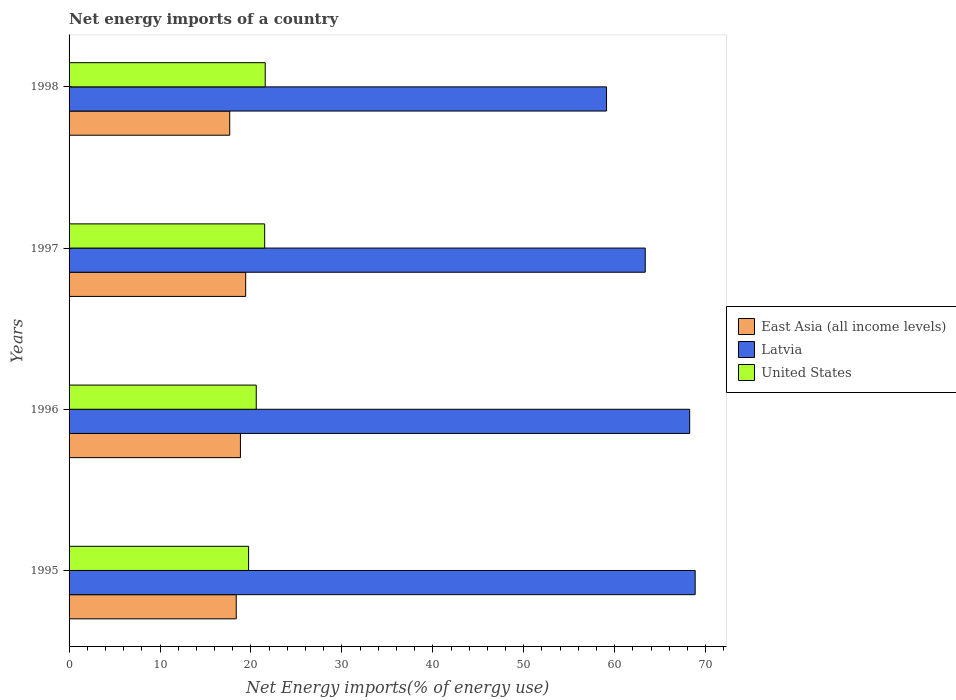How many different coloured bars are there?
Make the answer very short. 3. How many groups of bars are there?
Offer a terse response. 4. How many bars are there on the 2nd tick from the top?
Offer a terse response. 3. How many bars are there on the 1st tick from the bottom?
Give a very brief answer. 3. In how many cases, is the number of bars for a given year not equal to the number of legend labels?
Offer a very short reply. 0. What is the net energy imports in Latvia in 1997?
Offer a terse response. 63.36. Across all years, what is the maximum net energy imports in Latvia?
Provide a short and direct response. 68.85. Across all years, what is the minimum net energy imports in Latvia?
Your response must be concise. 59.1. In which year was the net energy imports in United States minimum?
Your response must be concise. 1995. What is the total net energy imports in East Asia (all income levels) in the graph?
Keep it short and to the point. 74.31. What is the difference between the net energy imports in East Asia (all income levels) in 1997 and that in 1998?
Your answer should be very brief. 1.75. What is the difference between the net energy imports in East Asia (all income levels) in 1996 and the net energy imports in United States in 1995?
Give a very brief answer. -0.9. What is the average net energy imports in United States per year?
Make the answer very short. 20.85. In the year 1995, what is the difference between the net energy imports in Latvia and net energy imports in United States?
Give a very brief answer. 49.11. What is the ratio of the net energy imports in United States in 1997 to that in 1998?
Provide a succinct answer. 1. What is the difference between the highest and the second highest net energy imports in Latvia?
Offer a terse response. 0.6. What is the difference between the highest and the lowest net energy imports in Latvia?
Make the answer very short. 9.75. In how many years, is the net energy imports in East Asia (all income levels) greater than the average net energy imports in East Asia (all income levels) taken over all years?
Ensure brevity in your answer.  2. What does the 2nd bar from the top in 1995 represents?
Your answer should be very brief. Latvia. What does the 2nd bar from the bottom in 1996 represents?
Provide a short and direct response. Latvia. How many bars are there?
Give a very brief answer. 12. How many years are there in the graph?
Keep it short and to the point. 4. What is the difference between two consecutive major ticks on the X-axis?
Offer a terse response. 10. Does the graph contain any zero values?
Offer a terse response. No. What is the title of the graph?
Your answer should be very brief. Net energy imports of a country. What is the label or title of the X-axis?
Your response must be concise. Net Energy imports(% of energy use). What is the label or title of the Y-axis?
Provide a short and direct response. Years. What is the Net Energy imports(% of energy use) in East Asia (all income levels) in 1995?
Offer a terse response. 18.38. What is the Net Energy imports(% of energy use) of Latvia in 1995?
Your response must be concise. 68.85. What is the Net Energy imports(% of energy use) in United States in 1995?
Give a very brief answer. 19.74. What is the Net Energy imports(% of energy use) of East Asia (all income levels) in 1996?
Provide a short and direct response. 18.84. What is the Net Energy imports(% of energy use) in Latvia in 1996?
Give a very brief answer. 68.25. What is the Net Energy imports(% of energy use) of United States in 1996?
Provide a short and direct response. 20.58. What is the Net Energy imports(% of energy use) of East Asia (all income levels) in 1997?
Your response must be concise. 19.42. What is the Net Energy imports(% of energy use) in Latvia in 1997?
Give a very brief answer. 63.36. What is the Net Energy imports(% of energy use) of United States in 1997?
Your response must be concise. 21.51. What is the Net Energy imports(% of energy use) in East Asia (all income levels) in 1998?
Your answer should be very brief. 17.67. What is the Net Energy imports(% of energy use) in Latvia in 1998?
Offer a very short reply. 59.1. What is the Net Energy imports(% of energy use) in United States in 1998?
Make the answer very short. 21.57. Across all years, what is the maximum Net Energy imports(% of energy use) of East Asia (all income levels)?
Ensure brevity in your answer.  19.42. Across all years, what is the maximum Net Energy imports(% of energy use) of Latvia?
Your response must be concise. 68.85. Across all years, what is the maximum Net Energy imports(% of energy use) in United States?
Your answer should be very brief. 21.57. Across all years, what is the minimum Net Energy imports(% of energy use) of East Asia (all income levels)?
Provide a succinct answer. 17.67. Across all years, what is the minimum Net Energy imports(% of energy use) of Latvia?
Make the answer very short. 59.1. Across all years, what is the minimum Net Energy imports(% of energy use) in United States?
Make the answer very short. 19.74. What is the total Net Energy imports(% of energy use) in East Asia (all income levels) in the graph?
Your answer should be very brief. 74.31. What is the total Net Energy imports(% of energy use) of Latvia in the graph?
Your answer should be very brief. 259.55. What is the total Net Energy imports(% of energy use) in United States in the graph?
Offer a very short reply. 83.4. What is the difference between the Net Energy imports(% of energy use) in East Asia (all income levels) in 1995 and that in 1996?
Your answer should be compact. -0.46. What is the difference between the Net Energy imports(% of energy use) in Latvia in 1995 and that in 1996?
Provide a succinct answer. 0.6. What is the difference between the Net Energy imports(% of energy use) in United States in 1995 and that in 1996?
Your answer should be very brief. -0.84. What is the difference between the Net Energy imports(% of energy use) of East Asia (all income levels) in 1995 and that in 1997?
Offer a very short reply. -1.04. What is the difference between the Net Energy imports(% of energy use) in Latvia in 1995 and that in 1997?
Offer a terse response. 5.49. What is the difference between the Net Energy imports(% of energy use) of United States in 1995 and that in 1997?
Ensure brevity in your answer.  -1.77. What is the difference between the Net Energy imports(% of energy use) of East Asia (all income levels) in 1995 and that in 1998?
Keep it short and to the point. 0.72. What is the difference between the Net Energy imports(% of energy use) in Latvia in 1995 and that in 1998?
Give a very brief answer. 9.75. What is the difference between the Net Energy imports(% of energy use) in United States in 1995 and that in 1998?
Keep it short and to the point. -1.83. What is the difference between the Net Energy imports(% of energy use) in East Asia (all income levels) in 1996 and that in 1997?
Ensure brevity in your answer.  -0.58. What is the difference between the Net Energy imports(% of energy use) in Latvia in 1996 and that in 1997?
Your response must be concise. 4.89. What is the difference between the Net Energy imports(% of energy use) in United States in 1996 and that in 1997?
Make the answer very short. -0.93. What is the difference between the Net Energy imports(% of energy use) of East Asia (all income levels) in 1996 and that in 1998?
Offer a terse response. 1.18. What is the difference between the Net Energy imports(% of energy use) in Latvia in 1996 and that in 1998?
Offer a terse response. 9.14. What is the difference between the Net Energy imports(% of energy use) of United States in 1996 and that in 1998?
Provide a succinct answer. -0.99. What is the difference between the Net Energy imports(% of energy use) in East Asia (all income levels) in 1997 and that in 1998?
Offer a terse response. 1.75. What is the difference between the Net Energy imports(% of energy use) in Latvia in 1997 and that in 1998?
Your answer should be compact. 4.26. What is the difference between the Net Energy imports(% of energy use) in United States in 1997 and that in 1998?
Your response must be concise. -0.06. What is the difference between the Net Energy imports(% of energy use) of East Asia (all income levels) in 1995 and the Net Energy imports(% of energy use) of Latvia in 1996?
Your answer should be very brief. -49.86. What is the difference between the Net Energy imports(% of energy use) in East Asia (all income levels) in 1995 and the Net Energy imports(% of energy use) in United States in 1996?
Offer a very short reply. -2.2. What is the difference between the Net Energy imports(% of energy use) in Latvia in 1995 and the Net Energy imports(% of energy use) in United States in 1996?
Keep it short and to the point. 48.27. What is the difference between the Net Energy imports(% of energy use) of East Asia (all income levels) in 1995 and the Net Energy imports(% of energy use) of Latvia in 1997?
Your answer should be very brief. -44.97. What is the difference between the Net Energy imports(% of energy use) of East Asia (all income levels) in 1995 and the Net Energy imports(% of energy use) of United States in 1997?
Offer a very short reply. -3.13. What is the difference between the Net Energy imports(% of energy use) in Latvia in 1995 and the Net Energy imports(% of energy use) in United States in 1997?
Make the answer very short. 47.34. What is the difference between the Net Energy imports(% of energy use) in East Asia (all income levels) in 1995 and the Net Energy imports(% of energy use) in Latvia in 1998?
Keep it short and to the point. -40.72. What is the difference between the Net Energy imports(% of energy use) in East Asia (all income levels) in 1995 and the Net Energy imports(% of energy use) in United States in 1998?
Make the answer very short. -3.19. What is the difference between the Net Energy imports(% of energy use) in Latvia in 1995 and the Net Energy imports(% of energy use) in United States in 1998?
Offer a terse response. 47.28. What is the difference between the Net Energy imports(% of energy use) in East Asia (all income levels) in 1996 and the Net Energy imports(% of energy use) in Latvia in 1997?
Your answer should be very brief. -44.51. What is the difference between the Net Energy imports(% of energy use) in East Asia (all income levels) in 1996 and the Net Energy imports(% of energy use) in United States in 1997?
Keep it short and to the point. -2.67. What is the difference between the Net Energy imports(% of energy use) of Latvia in 1996 and the Net Energy imports(% of energy use) of United States in 1997?
Keep it short and to the point. 46.74. What is the difference between the Net Energy imports(% of energy use) of East Asia (all income levels) in 1996 and the Net Energy imports(% of energy use) of Latvia in 1998?
Ensure brevity in your answer.  -40.26. What is the difference between the Net Energy imports(% of energy use) in East Asia (all income levels) in 1996 and the Net Energy imports(% of energy use) in United States in 1998?
Your response must be concise. -2.73. What is the difference between the Net Energy imports(% of energy use) of Latvia in 1996 and the Net Energy imports(% of energy use) of United States in 1998?
Ensure brevity in your answer.  46.68. What is the difference between the Net Energy imports(% of energy use) of East Asia (all income levels) in 1997 and the Net Energy imports(% of energy use) of Latvia in 1998?
Give a very brief answer. -39.68. What is the difference between the Net Energy imports(% of energy use) of East Asia (all income levels) in 1997 and the Net Energy imports(% of energy use) of United States in 1998?
Offer a very short reply. -2.15. What is the difference between the Net Energy imports(% of energy use) in Latvia in 1997 and the Net Energy imports(% of energy use) in United States in 1998?
Offer a terse response. 41.79. What is the average Net Energy imports(% of energy use) of East Asia (all income levels) per year?
Provide a short and direct response. 18.58. What is the average Net Energy imports(% of energy use) of Latvia per year?
Ensure brevity in your answer.  64.89. What is the average Net Energy imports(% of energy use) of United States per year?
Your answer should be compact. 20.85. In the year 1995, what is the difference between the Net Energy imports(% of energy use) in East Asia (all income levels) and Net Energy imports(% of energy use) in Latvia?
Your response must be concise. -50.47. In the year 1995, what is the difference between the Net Energy imports(% of energy use) of East Asia (all income levels) and Net Energy imports(% of energy use) of United States?
Offer a terse response. -1.36. In the year 1995, what is the difference between the Net Energy imports(% of energy use) in Latvia and Net Energy imports(% of energy use) in United States?
Offer a terse response. 49.11. In the year 1996, what is the difference between the Net Energy imports(% of energy use) in East Asia (all income levels) and Net Energy imports(% of energy use) in Latvia?
Your answer should be compact. -49.4. In the year 1996, what is the difference between the Net Energy imports(% of energy use) in East Asia (all income levels) and Net Energy imports(% of energy use) in United States?
Give a very brief answer. -1.74. In the year 1996, what is the difference between the Net Energy imports(% of energy use) in Latvia and Net Energy imports(% of energy use) in United States?
Provide a short and direct response. 47.66. In the year 1997, what is the difference between the Net Energy imports(% of energy use) in East Asia (all income levels) and Net Energy imports(% of energy use) in Latvia?
Provide a succinct answer. -43.94. In the year 1997, what is the difference between the Net Energy imports(% of energy use) of East Asia (all income levels) and Net Energy imports(% of energy use) of United States?
Keep it short and to the point. -2.09. In the year 1997, what is the difference between the Net Energy imports(% of energy use) of Latvia and Net Energy imports(% of energy use) of United States?
Keep it short and to the point. 41.85. In the year 1998, what is the difference between the Net Energy imports(% of energy use) of East Asia (all income levels) and Net Energy imports(% of energy use) of Latvia?
Offer a terse response. -41.43. In the year 1998, what is the difference between the Net Energy imports(% of energy use) of East Asia (all income levels) and Net Energy imports(% of energy use) of United States?
Your answer should be compact. -3.9. In the year 1998, what is the difference between the Net Energy imports(% of energy use) in Latvia and Net Energy imports(% of energy use) in United States?
Your response must be concise. 37.53. What is the ratio of the Net Energy imports(% of energy use) in East Asia (all income levels) in 1995 to that in 1996?
Provide a short and direct response. 0.98. What is the ratio of the Net Energy imports(% of energy use) in Latvia in 1995 to that in 1996?
Keep it short and to the point. 1.01. What is the ratio of the Net Energy imports(% of energy use) in United States in 1995 to that in 1996?
Keep it short and to the point. 0.96. What is the ratio of the Net Energy imports(% of energy use) of East Asia (all income levels) in 1995 to that in 1997?
Provide a succinct answer. 0.95. What is the ratio of the Net Energy imports(% of energy use) of Latvia in 1995 to that in 1997?
Ensure brevity in your answer.  1.09. What is the ratio of the Net Energy imports(% of energy use) in United States in 1995 to that in 1997?
Your response must be concise. 0.92. What is the ratio of the Net Energy imports(% of energy use) of East Asia (all income levels) in 1995 to that in 1998?
Your response must be concise. 1.04. What is the ratio of the Net Energy imports(% of energy use) of Latvia in 1995 to that in 1998?
Offer a very short reply. 1.16. What is the ratio of the Net Energy imports(% of energy use) of United States in 1995 to that in 1998?
Your answer should be very brief. 0.92. What is the ratio of the Net Energy imports(% of energy use) of East Asia (all income levels) in 1996 to that in 1997?
Your answer should be very brief. 0.97. What is the ratio of the Net Energy imports(% of energy use) of Latvia in 1996 to that in 1997?
Your response must be concise. 1.08. What is the ratio of the Net Energy imports(% of energy use) of United States in 1996 to that in 1997?
Your answer should be very brief. 0.96. What is the ratio of the Net Energy imports(% of energy use) in East Asia (all income levels) in 1996 to that in 1998?
Make the answer very short. 1.07. What is the ratio of the Net Energy imports(% of energy use) of Latvia in 1996 to that in 1998?
Offer a very short reply. 1.15. What is the ratio of the Net Energy imports(% of energy use) in United States in 1996 to that in 1998?
Your answer should be compact. 0.95. What is the ratio of the Net Energy imports(% of energy use) in East Asia (all income levels) in 1997 to that in 1998?
Offer a terse response. 1.1. What is the ratio of the Net Energy imports(% of energy use) of Latvia in 1997 to that in 1998?
Offer a terse response. 1.07. What is the ratio of the Net Energy imports(% of energy use) of United States in 1997 to that in 1998?
Ensure brevity in your answer.  1. What is the difference between the highest and the second highest Net Energy imports(% of energy use) in East Asia (all income levels)?
Give a very brief answer. 0.58. What is the difference between the highest and the second highest Net Energy imports(% of energy use) of Latvia?
Your answer should be compact. 0.6. What is the difference between the highest and the second highest Net Energy imports(% of energy use) of United States?
Provide a succinct answer. 0.06. What is the difference between the highest and the lowest Net Energy imports(% of energy use) in East Asia (all income levels)?
Your response must be concise. 1.75. What is the difference between the highest and the lowest Net Energy imports(% of energy use) of Latvia?
Make the answer very short. 9.75. What is the difference between the highest and the lowest Net Energy imports(% of energy use) of United States?
Give a very brief answer. 1.83. 